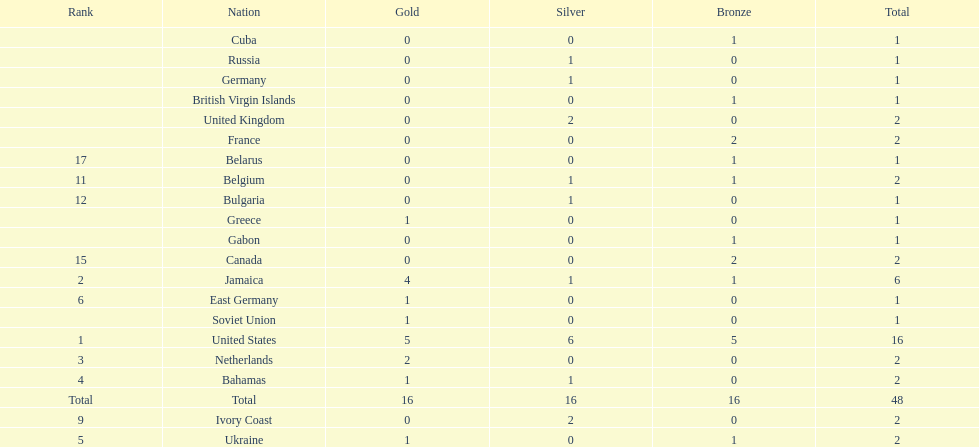How many gold medals did the us and jamaica win combined? 9. 